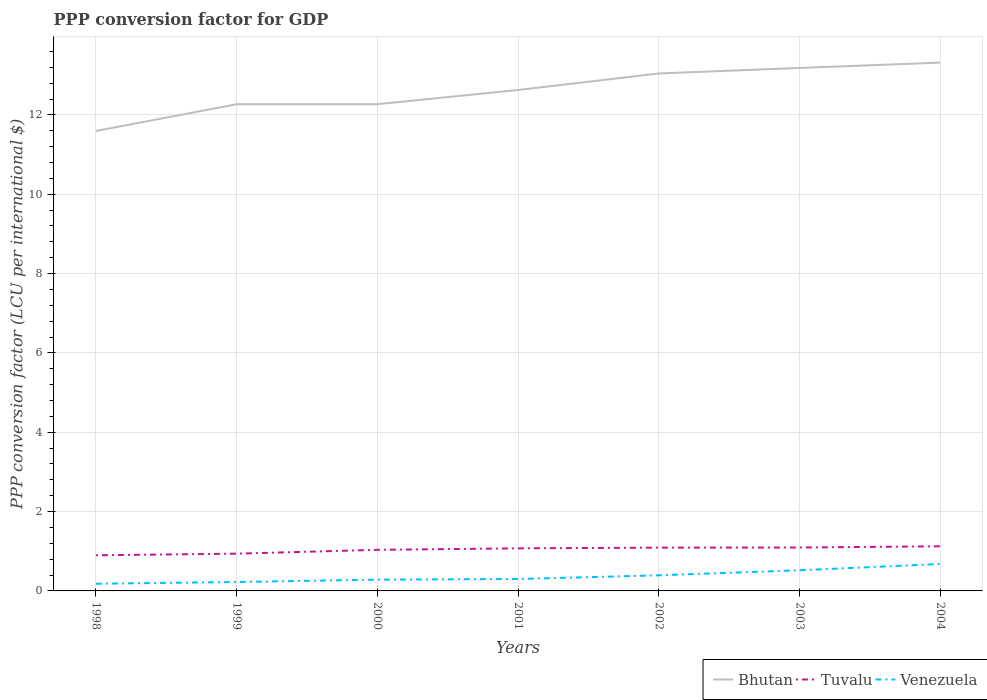How many different coloured lines are there?
Your answer should be very brief. 3. Does the line corresponding to Tuvalu intersect with the line corresponding to Venezuela?
Offer a terse response. No. Across all years, what is the maximum PPP conversion factor for GDP in Bhutan?
Provide a succinct answer. 11.59. In which year was the PPP conversion factor for GDP in Venezuela maximum?
Offer a terse response. 1998. What is the total PPP conversion factor for GDP in Tuvalu in the graph?
Your answer should be very brief. -0.05. What is the difference between the highest and the second highest PPP conversion factor for GDP in Venezuela?
Give a very brief answer. 0.5. What is the difference between the highest and the lowest PPP conversion factor for GDP in Tuvalu?
Make the answer very short. 4. Is the PPP conversion factor for GDP in Bhutan strictly greater than the PPP conversion factor for GDP in Venezuela over the years?
Your response must be concise. No. How many years are there in the graph?
Give a very brief answer. 7. Are the values on the major ticks of Y-axis written in scientific E-notation?
Make the answer very short. No. Does the graph contain grids?
Your response must be concise. Yes. Where does the legend appear in the graph?
Provide a succinct answer. Bottom right. How many legend labels are there?
Make the answer very short. 3. How are the legend labels stacked?
Keep it short and to the point. Horizontal. What is the title of the graph?
Offer a very short reply. PPP conversion factor for GDP. What is the label or title of the Y-axis?
Offer a very short reply. PPP conversion factor (LCU per international $). What is the PPP conversion factor (LCU per international $) in Bhutan in 1998?
Your answer should be compact. 11.59. What is the PPP conversion factor (LCU per international $) of Tuvalu in 1998?
Your answer should be compact. 0.9. What is the PPP conversion factor (LCU per international $) in Venezuela in 1998?
Keep it short and to the point. 0.18. What is the PPP conversion factor (LCU per international $) of Bhutan in 1999?
Your answer should be very brief. 12.27. What is the PPP conversion factor (LCU per international $) in Tuvalu in 1999?
Offer a terse response. 0.94. What is the PPP conversion factor (LCU per international $) of Venezuela in 1999?
Provide a short and direct response. 0.22. What is the PPP conversion factor (LCU per international $) of Bhutan in 2000?
Provide a succinct answer. 12.27. What is the PPP conversion factor (LCU per international $) in Tuvalu in 2000?
Ensure brevity in your answer.  1.04. What is the PPP conversion factor (LCU per international $) of Venezuela in 2000?
Give a very brief answer. 0.28. What is the PPP conversion factor (LCU per international $) of Bhutan in 2001?
Your answer should be very brief. 12.63. What is the PPP conversion factor (LCU per international $) in Tuvalu in 2001?
Offer a terse response. 1.07. What is the PPP conversion factor (LCU per international $) of Venezuela in 2001?
Your response must be concise. 0.3. What is the PPP conversion factor (LCU per international $) of Bhutan in 2002?
Offer a very short reply. 13.05. What is the PPP conversion factor (LCU per international $) of Tuvalu in 2002?
Make the answer very short. 1.09. What is the PPP conversion factor (LCU per international $) of Venezuela in 2002?
Keep it short and to the point. 0.39. What is the PPP conversion factor (LCU per international $) in Bhutan in 2003?
Ensure brevity in your answer.  13.18. What is the PPP conversion factor (LCU per international $) of Tuvalu in 2003?
Your answer should be compact. 1.09. What is the PPP conversion factor (LCU per international $) in Venezuela in 2003?
Your answer should be very brief. 0.52. What is the PPP conversion factor (LCU per international $) of Bhutan in 2004?
Keep it short and to the point. 13.32. What is the PPP conversion factor (LCU per international $) in Tuvalu in 2004?
Your answer should be compact. 1.12. What is the PPP conversion factor (LCU per international $) in Venezuela in 2004?
Provide a succinct answer. 0.68. Across all years, what is the maximum PPP conversion factor (LCU per international $) of Bhutan?
Offer a terse response. 13.32. Across all years, what is the maximum PPP conversion factor (LCU per international $) in Tuvalu?
Offer a terse response. 1.12. Across all years, what is the maximum PPP conversion factor (LCU per international $) of Venezuela?
Your answer should be compact. 0.68. Across all years, what is the minimum PPP conversion factor (LCU per international $) in Bhutan?
Your answer should be compact. 11.59. Across all years, what is the minimum PPP conversion factor (LCU per international $) of Tuvalu?
Offer a terse response. 0.9. Across all years, what is the minimum PPP conversion factor (LCU per international $) of Venezuela?
Your answer should be compact. 0.18. What is the total PPP conversion factor (LCU per international $) in Bhutan in the graph?
Make the answer very short. 88.31. What is the total PPP conversion factor (LCU per international $) in Tuvalu in the graph?
Make the answer very short. 7.26. What is the total PPP conversion factor (LCU per international $) of Venezuela in the graph?
Ensure brevity in your answer.  2.59. What is the difference between the PPP conversion factor (LCU per international $) of Bhutan in 1998 and that in 1999?
Provide a succinct answer. -0.67. What is the difference between the PPP conversion factor (LCU per international $) of Tuvalu in 1998 and that in 1999?
Give a very brief answer. -0.04. What is the difference between the PPP conversion factor (LCU per international $) of Venezuela in 1998 and that in 1999?
Give a very brief answer. -0.04. What is the difference between the PPP conversion factor (LCU per international $) of Bhutan in 1998 and that in 2000?
Provide a succinct answer. -0.68. What is the difference between the PPP conversion factor (LCU per international $) of Tuvalu in 1998 and that in 2000?
Ensure brevity in your answer.  -0.14. What is the difference between the PPP conversion factor (LCU per international $) of Venezuela in 1998 and that in 2000?
Make the answer very short. -0.1. What is the difference between the PPP conversion factor (LCU per international $) in Bhutan in 1998 and that in 2001?
Ensure brevity in your answer.  -1.03. What is the difference between the PPP conversion factor (LCU per international $) of Tuvalu in 1998 and that in 2001?
Give a very brief answer. -0.17. What is the difference between the PPP conversion factor (LCU per international $) of Venezuela in 1998 and that in 2001?
Make the answer very short. -0.12. What is the difference between the PPP conversion factor (LCU per international $) of Bhutan in 1998 and that in 2002?
Your response must be concise. -1.45. What is the difference between the PPP conversion factor (LCU per international $) of Tuvalu in 1998 and that in 2002?
Your answer should be compact. -0.19. What is the difference between the PPP conversion factor (LCU per international $) of Venezuela in 1998 and that in 2002?
Your response must be concise. -0.21. What is the difference between the PPP conversion factor (LCU per international $) of Bhutan in 1998 and that in 2003?
Your answer should be compact. -1.59. What is the difference between the PPP conversion factor (LCU per international $) in Tuvalu in 1998 and that in 2003?
Give a very brief answer. -0.2. What is the difference between the PPP conversion factor (LCU per international $) of Venezuela in 1998 and that in 2003?
Keep it short and to the point. -0.34. What is the difference between the PPP conversion factor (LCU per international $) of Bhutan in 1998 and that in 2004?
Your answer should be very brief. -1.72. What is the difference between the PPP conversion factor (LCU per international $) of Tuvalu in 1998 and that in 2004?
Your answer should be very brief. -0.23. What is the difference between the PPP conversion factor (LCU per international $) in Venezuela in 1998 and that in 2004?
Give a very brief answer. -0.5. What is the difference between the PPP conversion factor (LCU per international $) in Bhutan in 1999 and that in 2000?
Keep it short and to the point. -0. What is the difference between the PPP conversion factor (LCU per international $) of Tuvalu in 1999 and that in 2000?
Offer a terse response. -0.1. What is the difference between the PPP conversion factor (LCU per international $) of Venezuela in 1999 and that in 2000?
Provide a short and direct response. -0.06. What is the difference between the PPP conversion factor (LCU per international $) in Bhutan in 1999 and that in 2001?
Make the answer very short. -0.36. What is the difference between the PPP conversion factor (LCU per international $) in Tuvalu in 1999 and that in 2001?
Offer a terse response. -0.13. What is the difference between the PPP conversion factor (LCU per international $) in Venezuela in 1999 and that in 2001?
Offer a terse response. -0.08. What is the difference between the PPP conversion factor (LCU per international $) of Bhutan in 1999 and that in 2002?
Provide a short and direct response. -0.78. What is the difference between the PPP conversion factor (LCU per international $) in Tuvalu in 1999 and that in 2002?
Offer a terse response. -0.15. What is the difference between the PPP conversion factor (LCU per international $) of Venezuela in 1999 and that in 2002?
Your response must be concise. -0.17. What is the difference between the PPP conversion factor (LCU per international $) of Bhutan in 1999 and that in 2003?
Your answer should be very brief. -0.92. What is the difference between the PPP conversion factor (LCU per international $) in Tuvalu in 1999 and that in 2003?
Ensure brevity in your answer.  -0.16. What is the difference between the PPP conversion factor (LCU per international $) of Venezuela in 1999 and that in 2003?
Provide a succinct answer. -0.3. What is the difference between the PPP conversion factor (LCU per international $) of Bhutan in 1999 and that in 2004?
Provide a short and direct response. -1.05. What is the difference between the PPP conversion factor (LCU per international $) of Tuvalu in 1999 and that in 2004?
Your response must be concise. -0.19. What is the difference between the PPP conversion factor (LCU per international $) of Venezuela in 1999 and that in 2004?
Your answer should be very brief. -0.45. What is the difference between the PPP conversion factor (LCU per international $) of Bhutan in 2000 and that in 2001?
Provide a short and direct response. -0.36. What is the difference between the PPP conversion factor (LCU per international $) of Tuvalu in 2000 and that in 2001?
Provide a succinct answer. -0.04. What is the difference between the PPP conversion factor (LCU per international $) in Venezuela in 2000 and that in 2001?
Your answer should be compact. -0.02. What is the difference between the PPP conversion factor (LCU per international $) of Bhutan in 2000 and that in 2002?
Your response must be concise. -0.77. What is the difference between the PPP conversion factor (LCU per international $) of Tuvalu in 2000 and that in 2002?
Your answer should be very brief. -0.06. What is the difference between the PPP conversion factor (LCU per international $) of Venezuela in 2000 and that in 2002?
Your response must be concise. -0.11. What is the difference between the PPP conversion factor (LCU per international $) of Bhutan in 2000 and that in 2003?
Your answer should be compact. -0.91. What is the difference between the PPP conversion factor (LCU per international $) of Tuvalu in 2000 and that in 2003?
Keep it short and to the point. -0.06. What is the difference between the PPP conversion factor (LCU per international $) in Venezuela in 2000 and that in 2003?
Your answer should be compact. -0.24. What is the difference between the PPP conversion factor (LCU per international $) in Bhutan in 2000 and that in 2004?
Your response must be concise. -1.05. What is the difference between the PPP conversion factor (LCU per international $) of Tuvalu in 2000 and that in 2004?
Give a very brief answer. -0.09. What is the difference between the PPP conversion factor (LCU per international $) of Venezuela in 2000 and that in 2004?
Make the answer very short. -0.39. What is the difference between the PPP conversion factor (LCU per international $) of Bhutan in 2001 and that in 2002?
Make the answer very short. -0.42. What is the difference between the PPP conversion factor (LCU per international $) in Tuvalu in 2001 and that in 2002?
Keep it short and to the point. -0.02. What is the difference between the PPP conversion factor (LCU per international $) in Venezuela in 2001 and that in 2002?
Provide a succinct answer. -0.09. What is the difference between the PPP conversion factor (LCU per international $) of Bhutan in 2001 and that in 2003?
Offer a very short reply. -0.56. What is the difference between the PPP conversion factor (LCU per international $) in Tuvalu in 2001 and that in 2003?
Offer a terse response. -0.02. What is the difference between the PPP conversion factor (LCU per international $) in Venezuela in 2001 and that in 2003?
Your answer should be very brief. -0.22. What is the difference between the PPP conversion factor (LCU per international $) of Bhutan in 2001 and that in 2004?
Offer a terse response. -0.69. What is the difference between the PPP conversion factor (LCU per international $) of Tuvalu in 2001 and that in 2004?
Provide a short and direct response. -0.05. What is the difference between the PPP conversion factor (LCU per international $) of Venezuela in 2001 and that in 2004?
Ensure brevity in your answer.  -0.38. What is the difference between the PPP conversion factor (LCU per international $) in Bhutan in 2002 and that in 2003?
Give a very brief answer. -0.14. What is the difference between the PPP conversion factor (LCU per international $) of Tuvalu in 2002 and that in 2003?
Offer a very short reply. -0. What is the difference between the PPP conversion factor (LCU per international $) of Venezuela in 2002 and that in 2003?
Keep it short and to the point. -0.13. What is the difference between the PPP conversion factor (LCU per international $) in Bhutan in 2002 and that in 2004?
Your response must be concise. -0.27. What is the difference between the PPP conversion factor (LCU per international $) of Tuvalu in 2002 and that in 2004?
Your response must be concise. -0.03. What is the difference between the PPP conversion factor (LCU per international $) in Venezuela in 2002 and that in 2004?
Give a very brief answer. -0.29. What is the difference between the PPP conversion factor (LCU per international $) of Bhutan in 2003 and that in 2004?
Your answer should be very brief. -0.13. What is the difference between the PPP conversion factor (LCU per international $) of Tuvalu in 2003 and that in 2004?
Keep it short and to the point. -0.03. What is the difference between the PPP conversion factor (LCU per international $) of Venezuela in 2003 and that in 2004?
Offer a very short reply. -0.16. What is the difference between the PPP conversion factor (LCU per international $) of Bhutan in 1998 and the PPP conversion factor (LCU per international $) of Tuvalu in 1999?
Your answer should be compact. 10.66. What is the difference between the PPP conversion factor (LCU per international $) of Bhutan in 1998 and the PPP conversion factor (LCU per international $) of Venezuela in 1999?
Your answer should be very brief. 11.37. What is the difference between the PPP conversion factor (LCU per international $) of Tuvalu in 1998 and the PPP conversion factor (LCU per international $) of Venezuela in 1999?
Ensure brevity in your answer.  0.67. What is the difference between the PPP conversion factor (LCU per international $) of Bhutan in 1998 and the PPP conversion factor (LCU per international $) of Tuvalu in 2000?
Your answer should be compact. 10.56. What is the difference between the PPP conversion factor (LCU per international $) in Bhutan in 1998 and the PPP conversion factor (LCU per international $) in Venezuela in 2000?
Offer a terse response. 11.31. What is the difference between the PPP conversion factor (LCU per international $) of Tuvalu in 1998 and the PPP conversion factor (LCU per international $) of Venezuela in 2000?
Provide a succinct answer. 0.61. What is the difference between the PPP conversion factor (LCU per international $) of Bhutan in 1998 and the PPP conversion factor (LCU per international $) of Tuvalu in 2001?
Offer a terse response. 10.52. What is the difference between the PPP conversion factor (LCU per international $) in Bhutan in 1998 and the PPP conversion factor (LCU per international $) in Venezuela in 2001?
Your answer should be very brief. 11.29. What is the difference between the PPP conversion factor (LCU per international $) of Tuvalu in 1998 and the PPP conversion factor (LCU per international $) of Venezuela in 2001?
Give a very brief answer. 0.6. What is the difference between the PPP conversion factor (LCU per international $) in Bhutan in 1998 and the PPP conversion factor (LCU per international $) in Tuvalu in 2002?
Your response must be concise. 10.5. What is the difference between the PPP conversion factor (LCU per international $) in Bhutan in 1998 and the PPP conversion factor (LCU per international $) in Venezuela in 2002?
Offer a very short reply. 11.2. What is the difference between the PPP conversion factor (LCU per international $) of Tuvalu in 1998 and the PPP conversion factor (LCU per international $) of Venezuela in 2002?
Your answer should be compact. 0.5. What is the difference between the PPP conversion factor (LCU per international $) in Bhutan in 1998 and the PPP conversion factor (LCU per international $) in Tuvalu in 2003?
Your answer should be very brief. 10.5. What is the difference between the PPP conversion factor (LCU per international $) of Bhutan in 1998 and the PPP conversion factor (LCU per international $) of Venezuela in 2003?
Provide a succinct answer. 11.07. What is the difference between the PPP conversion factor (LCU per international $) in Tuvalu in 1998 and the PPP conversion factor (LCU per international $) in Venezuela in 2003?
Give a very brief answer. 0.38. What is the difference between the PPP conversion factor (LCU per international $) of Bhutan in 1998 and the PPP conversion factor (LCU per international $) of Tuvalu in 2004?
Your response must be concise. 10.47. What is the difference between the PPP conversion factor (LCU per international $) of Bhutan in 1998 and the PPP conversion factor (LCU per international $) of Venezuela in 2004?
Provide a short and direct response. 10.92. What is the difference between the PPP conversion factor (LCU per international $) of Tuvalu in 1998 and the PPP conversion factor (LCU per international $) of Venezuela in 2004?
Your response must be concise. 0.22. What is the difference between the PPP conversion factor (LCU per international $) in Bhutan in 1999 and the PPP conversion factor (LCU per international $) in Tuvalu in 2000?
Ensure brevity in your answer.  11.23. What is the difference between the PPP conversion factor (LCU per international $) in Bhutan in 1999 and the PPP conversion factor (LCU per international $) in Venezuela in 2000?
Offer a very short reply. 11.98. What is the difference between the PPP conversion factor (LCU per international $) in Tuvalu in 1999 and the PPP conversion factor (LCU per international $) in Venezuela in 2000?
Provide a short and direct response. 0.65. What is the difference between the PPP conversion factor (LCU per international $) in Bhutan in 1999 and the PPP conversion factor (LCU per international $) in Tuvalu in 2001?
Keep it short and to the point. 11.2. What is the difference between the PPP conversion factor (LCU per international $) in Bhutan in 1999 and the PPP conversion factor (LCU per international $) in Venezuela in 2001?
Give a very brief answer. 11.97. What is the difference between the PPP conversion factor (LCU per international $) of Tuvalu in 1999 and the PPP conversion factor (LCU per international $) of Venezuela in 2001?
Your answer should be very brief. 0.64. What is the difference between the PPP conversion factor (LCU per international $) in Bhutan in 1999 and the PPP conversion factor (LCU per international $) in Tuvalu in 2002?
Ensure brevity in your answer.  11.18. What is the difference between the PPP conversion factor (LCU per international $) in Bhutan in 1999 and the PPP conversion factor (LCU per international $) in Venezuela in 2002?
Offer a very short reply. 11.88. What is the difference between the PPP conversion factor (LCU per international $) of Tuvalu in 1999 and the PPP conversion factor (LCU per international $) of Venezuela in 2002?
Provide a succinct answer. 0.55. What is the difference between the PPP conversion factor (LCU per international $) of Bhutan in 1999 and the PPP conversion factor (LCU per international $) of Tuvalu in 2003?
Offer a very short reply. 11.17. What is the difference between the PPP conversion factor (LCU per international $) of Bhutan in 1999 and the PPP conversion factor (LCU per international $) of Venezuela in 2003?
Offer a very short reply. 11.75. What is the difference between the PPP conversion factor (LCU per international $) in Tuvalu in 1999 and the PPP conversion factor (LCU per international $) in Venezuela in 2003?
Offer a terse response. 0.42. What is the difference between the PPP conversion factor (LCU per international $) of Bhutan in 1999 and the PPP conversion factor (LCU per international $) of Tuvalu in 2004?
Ensure brevity in your answer.  11.14. What is the difference between the PPP conversion factor (LCU per international $) in Bhutan in 1999 and the PPP conversion factor (LCU per international $) in Venezuela in 2004?
Keep it short and to the point. 11.59. What is the difference between the PPP conversion factor (LCU per international $) of Tuvalu in 1999 and the PPP conversion factor (LCU per international $) of Venezuela in 2004?
Give a very brief answer. 0.26. What is the difference between the PPP conversion factor (LCU per international $) in Bhutan in 2000 and the PPP conversion factor (LCU per international $) in Tuvalu in 2001?
Provide a short and direct response. 11.2. What is the difference between the PPP conversion factor (LCU per international $) of Bhutan in 2000 and the PPP conversion factor (LCU per international $) of Venezuela in 2001?
Keep it short and to the point. 11.97. What is the difference between the PPP conversion factor (LCU per international $) in Tuvalu in 2000 and the PPP conversion factor (LCU per international $) in Venezuela in 2001?
Make the answer very short. 0.74. What is the difference between the PPP conversion factor (LCU per international $) of Bhutan in 2000 and the PPP conversion factor (LCU per international $) of Tuvalu in 2002?
Ensure brevity in your answer.  11.18. What is the difference between the PPP conversion factor (LCU per international $) in Bhutan in 2000 and the PPP conversion factor (LCU per international $) in Venezuela in 2002?
Offer a terse response. 11.88. What is the difference between the PPP conversion factor (LCU per international $) in Tuvalu in 2000 and the PPP conversion factor (LCU per international $) in Venezuela in 2002?
Offer a terse response. 0.64. What is the difference between the PPP conversion factor (LCU per international $) in Bhutan in 2000 and the PPP conversion factor (LCU per international $) in Tuvalu in 2003?
Your answer should be very brief. 11.18. What is the difference between the PPP conversion factor (LCU per international $) in Bhutan in 2000 and the PPP conversion factor (LCU per international $) in Venezuela in 2003?
Ensure brevity in your answer.  11.75. What is the difference between the PPP conversion factor (LCU per international $) in Tuvalu in 2000 and the PPP conversion factor (LCU per international $) in Venezuela in 2003?
Your answer should be compact. 0.52. What is the difference between the PPP conversion factor (LCU per international $) of Bhutan in 2000 and the PPP conversion factor (LCU per international $) of Tuvalu in 2004?
Provide a short and direct response. 11.15. What is the difference between the PPP conversion factor (LCU per international $) of Bhutan in 2000 and the PPP conversion factor (LCU per international $) of Venezuela in 2004?
Provide a short and direct response. 11.59. What is the difference between the PPP conversion factor (LCU per international $) in Tuvalu in 2000 and the PPP conversion factor (LCU per international $) in Venezuela in 2004?
Provide a short and direct response. 0.36. What is the difference between the PPP conversion factor (LCU per international $) in Bhutan in 2001 and the PPP conversion factor (LCU per international $) in Tuvalu in 2002?
Offer a terse response. 11.54. What is the difference between the PPP conversion factor (LCU per international $) in Bhutan in 2001 and the PPP conversion factor (LCU per international $) in Venezuela in 2002?
Offer a very short reply. 12.23. What is the difference between the PPP conversion factor (LCU per international $) of Tuvalu in 2001 and the PPP conversion factor (LCU per international $) of Venezuela in 2002?
Keep it short and to the point. 0.68. What is the difference between the PPP conversion factor (LCU per international $) in Bhutan in 2001 and the PPP conversion factor (LCU per international $) in Tuvalu in 2003?
Ensure brevity in your answer.  11.53. What is the difference between the PPP conversion factor (LCU per international $) of Bhutan in 2001 and the PPP conversion factor (LCU per international $) of Venezuela in 2003?
Your answer should be compact. 12.11. What is the difference between the PPP conversion factor (LCU per international $) of Tuvalu in 2001 and the PPP conversion factor (LCU per international $) of Venezuela in 2003?
Your response must be concise. 0.55. What is the difference between the PPP conversion factor (LCU per international $) of Bhutan in 2001 and the PPP conversion factor (LCU per international $) of Tuvalu in 2004?
Keep it short and to the point. 11.5. What is the difference between the PPP conversion factor (LCU per international $) in Bhutan in 2001 and the PPP conversion factor (LCU per international $) in Venezuela in 2004?
Offer a terse response. 11.95. What is the difference between the PPP conversion factor (LCU per international $) of Tuvalu in 2001 and the PPP conversion factor (LCU per international $) of Venezuela in 2004?
Your response must be concise. 0.39. What is the difference between the PPP conversion factor (LCU per international $) in Bhutan in 2002 and the PPP conversion factor (LCU per international $) in Tuvalu in 2003?
Ensure brevity in your answer.  11.95. What is the difference between the PPP conversion factor (LCU per international $) in Bhutan in 2002 and the PPP conversion factor (LCU per international $) in Venezuela in 2003?
Your response must be concise. 12.52. What is the difference between the PPP conversion factor (LCU per international $) in Tuvalu in 2002 and the PPP conversion factor (LCU per international $) in Venezuela in 2003?
Your answer should be compact. 0.57. What is the difference between the PPP conversion factor (LCU per international $) in Bhutan in 2002 and the PPP conversion factor (LCU per international $) in Tuvalu in 2004?
Give a very brief answer. 11.92. What is the difference between the PPP conversion factor (LCU per international $) in Bhutan in 2002 and the PPP conversion factor (LCU per international $) in Venezuela in 2004?
Keep it short and to the point. 12.37. What is the difference between the PPP conversion factor (LCU per international $) of Tuvalu in 2002 and the PPP conversion factor (LCU per international $) of Venezuela in 2004?
Ensure brevity in your answer.  0.41. What is the difference between the PPP conversion factor (LCU per international $) in Bhutan in 2003 and the PPP conversion factor (LCU per international $) in Tuvalu in 2004?
Provide a short and direct response. 12.06. What is the difference between the PPP conversion factor (LCU per international $) in Bhutan in 2003 and the PPP conversion factor (LCU per international $) in Venezuela in 2004?
Provide a succinct answer. 12.51. What is the difference between the PPP conversion factor (LCU per international $) in Tuvalu in 2003 and the PPP conversion factor (LCU per international $) in Venezuela in 2004?
Your answer should be compact. 0.42. What is the average PPP conversion factor (LCU per international $) of Bhutan per year?
Give a very brief answer. 12.62. What is the average PPP conversion factor (LCU per international $) of Tuvalu per year?
Your response must be concise. 1.04. What is the average PPP conversion factor (LCU per international $) in Venezuela per year?
Offer a terse response. 0.37. In the year 1998, what is the difference between the PPP conversion factor (LCU per international $) in Bhutan and PPP conversion factor (LCU per international $) in Tuvalu?
Your answer should be very brief. 10.7. In the year 1998, what is the difference between the PPP conversion factor (LCU per international $) of Bhutan and PPP conversion factor (LCU per international $) of Venezuela?
Your response must be concise. 11.41. In the year 1998, what is the difference between the PPP conversion factor (LCU per international $) in Tuvalu and PPP conversion factor (LCU per international $) in Venezuela?
Provide a succinct answer. 0.72. In the year 1999, what is the difference between the PPP conversion factor (LCU per international $) in Bhutan and PPP conversion factor (LCU per international $) in Tuvalu?
Your answer should be very brief. 11.33. In the year 1999, what is the difference between the PPP conversion factor (LCU per international $) in Bhutan and PPP conversion factor (LCU per international $) in Venezuela?
Ensure brevity in your answer.  12.04. In the year 1999, what is the difference between the PPP conversion factor (LCU per international $) in Tuvalu and PPP conversion factor (LCU per international $) in Venezuela?
Make the answer very short. 0.71. In the year 2000, what is the difference between the PPP conversion factor (LCU per international $) in Bhutan and PPP conversion factor (LCU per international $) in Tuvalu?
Your answer should be very brief. 11.23. In the year 2000, what is the difference between the PPP conversion factor (LCU per international $) in Bhutan and PPP conversion factor (LCU per international $) in Venezuela?
Your response must be concise. 11.99. In the year 2000, what is the difference between the PPP conversion factor (LCU per international $) in Tuvalu and PPP conversion factor (LCU per international $) in Venezuela?
Your answer should be compact. 0.75. In the year 2001, what is the difference between the PPP conversion factor (LCU per international $) of Bhutan and PPP conversion factor (LCU per international $) of Tuvalu?
Provide a short and direct response. 11.56. In the year 2001, what is the difference between the PPP conversion factor (LCU per international $) in Bhutan and PPP conversion factor (LCU per international $) in Venezuela?
Your response must be concise. 12.33. In the year 2001, what is the difference between the PPP conversion factor (LCU per international $) in Tuvalu and PPP conversion factor (LCU per international $) in Venezuela?
Your answer should be compact. 0.77. In the year 2002, what is the difference between the PPP conversion factor (LCU per international $) of Bhutan and PPP conversion factor (LCU per international $) of Tuvalu?
Your answer should be very brief. 11.95. In the year 2002, what is the difference between the PPP conversion factor (LCU per international $) of Bhutan and PPP conversion factor (LCU per international $) of Venezuela?
Give a very brief answer. 12.65. In the year 2002, what is the difference between the PPP conversion factor (LCU per international $) in Tuvalu and PPP conversion factor (LCU per international $) in Venezuela?
Offer a very short reply. 0.7. In the year 2003, what is the difference between the PPP conversion factor (LCU per international $) in Bhutan and PPP conversion factor (LCU per international $) in Tuvalu?
Your response must be concise. 12.09. In the year 2003, what is the difference between the PPP conversion factor (LCU per international $) in Bhutan and PPP conversion factor (LCU per international $) in Venezuela?
Your response must be concise. 12.66. In the year 2003, what is the difference between the PPP conversion factor (LCU per international $) of Tuvalu and PPP conversion factor (LCU per international $) of Venezuela?
Provide a short and direct response. 0.57. In the year 2004, what is the difference between the PPP conversion factor (LCU per international $) of Bhutan and PPP conversion factor (LCU per international $) of Tuvalu?
Your answer should be compact. 12.19. In the year 2004, what is the difference between the PPP conversion factor (LCU per international $) in Bhutan and PPP conversion factor (LCU per international $) in Venezuela?
Give a very brief answer. 12.64. In the year 2004, what is the difference between the PPP conversion factor (LCU per international $) of Tuvalu and PPP conversion factor (LCU per international $) of Venezuela?
Your answer should be very brief. 0.45. What is the ratio of the PPP conversion factor (LCU per international $) in Bhutan in 1998 to that in 1999?
Make the answer very short. 0.94. What is the ratio of the PPP conversion factor (LCU per international $) in Tuvalu in 1998 to that in 1999?
Keep it short and to the point. 0.96. What is the ratio of the PPP conversion factor (LCU per international $) in Venezuela in 1998 to that in 1999?
Give a very brief answer. 0.8. What is the ratio of the PPP conversion factor (LCU per international $) in Bhutan in 1998 to that in 2000?
Your response must be concise. 0.94. What is the ratio of the PPP conversion factor (LCU per international $) in Tuvalu in 1998 to that in 2000?
Make the answer very short. 0.87. What is the ratio of the PPP conversion factor (LCU per international $) in Venezuela in 1998 to that in 2000?
Provide a short and direct response. 0.64. What is the ratio of the PPP conversion factor (LCU per international $) of Bhutan in 1998 to that in 2001?
Ensure brevity in your answer.  0.92. What is the ratio of the PPP conversion factor (LCU per international $) in Tuvalu in 1998 to that in 2001?
Keep it short and to the point. 0.84. What is the ratio of the PPP conversion factor (LCU per international $) in Venezuela in 1998 to that in 2001?
Your response must be concise. 0.6. What is the ratio of the PPP conversion factor (LCU per international $) in Bhutan in 1998 to that in 2002?
Provide a succinct answer. 0.89. What is the ratio of the PPP conversion factor (LCU per international $) of Tuvalu in 1998 to that in 2002?
Provide a succinct answer. 0.82. What is the ratio of the PPP conversion factor (LCU per international $) of Venezuela in 1998 to that in 2002?
Offer a terse response. 0.46. What is the ratio of the PPP conversion factor (LCU per international $) of Bhutan in 1998 to that in 2003?
Your response must be concise. 0.88. What is the ratio of the PPP conversion factor (LCU per international $) in Tuvalu in 1998 to that in 2003?
Your answer should be compact. 0.82. What is the ratio of the PPP conversion factor (LCU per international $) in Venezuela in 1998 to that in 2003?
Offer a very short reply. 0.35. What is the ratio of the PPP conversion factor (LCU per international $) in Bhutan in 1998 to that in 2004?
Provide a succinct answer. 0.87. What is the ratio of the PPP conversion factor (LCU per international $) of Tuvalu in 1998 to that in 2004?
Make the answer very short. 0.8. What is the ratio of the PPP conversion factor (LCU per international $) in Venezuela in 1998 to that in 2004?
Keep it short and to the point. 0.27. What is the ratio of the PPP conversion factor (LCU per international $) in Bhutan in 1999 to that in 2000?
Offer a terse response. 1. What is the ratio of the PPP conversion factor (LCU per international $) of Tuvalu in 1999 to that in 2000?
Make the answer very short. 0.91. What is the ratio of the PPP conversion factor (LCU per international $) in Venezuela in 1999 to that in 2000?
Offer a terse response. 0.79. What is the ratio of the PPP conversion factor (LCU per international $) of Bhutan in 1999 to that in 2001?
Your response must be concise. 0.97. What is the ratio of the PPP conversion factor (LCU per international $) of Tuvalu in 1999 to that in 2001?
Offer a terse response. 0.88. What is the ratio of the PPP conversion factor (LCU per international $) in Venezuela in 1999 to that in 2001?
Ensure brevity in your answer.  0.75. What is the ratio of the PPP conversion factor (LCU per international $) of Bhutan in 1999 to that in 2002?
Provide a succinct answer. 0.94. What is the ratio of the PPP conversion factor (LCU per international $) of Tuvalu in 1999 to that in 2002?
Ensure brevity in your answer.  0.86. What is the ratio of the PPP conversion factor (LCU per international $) in Venezuela in 1999 to that in 2002?
Ensure brevity in your answer.  0.57. What is the ratio of the PPP conversion factor (LCU per international $) of Bhutan in 1999 to that in 2003?
Ensure brevity in your answer.  0.93. What is the ratio of the PPP conversion factor (LCU per international $) of Tuvalu in 1999 to that in 2003?
Provide a succinct answer. 0.86. What is the ratio of the PPP conversion factor (LCU per international $) of Venezuela in 1999 to that in 2003?
Make the answer very short. 0.43. What is the ratio of the PPP conversion factor (LCU per international $) in Bhutan in 1999 to that in 2004?
Make the answer very short. 0.92. What is the ratio of the PPP conversion factor (LCU per international $) of Tuvalu in 1999 to that in 2004?
Offer a very short reply. 0.83. What is the ratio of the PPP conversion factor (LCU per international $) of Venezuela in 1999 to that in 2004?
Keep it short and to the point. 0.33. What is the ratio of the PPP conversion factor (LCU per international $) of Bhutan in 2000 to that in 2001?
Offer a terse response. 0.97. What is the ratio of the PPP conversion factor (LCU per international $) of Tuvalu in 2000 to that in 2001?
Offer a very short reply. 0.97. What is the ratio of the PPP conversion factor (LCU per international $) of Venezuela in 2000 to that in 2001?
Ensure brevity in your answer.  0.95. What is the ratio of the PPP conversion factor (LCU per international $) of Bhutan in 2000 to that in 2002?
Provide a succinct answer. 0.94. What is the ratio of the PPP conversion factor (LCU per international $) in Tuvalu in 2000 to that in 2002?
Offer a terse response. 0.95. What is the ratio of the PPP conversion factor (LCU per international $) of Venezuela in 2000 to that in 2002?
Provide a short and direct response. 0.72. What is the ratio of the PPP conversion factor (LCU per international $) of Bhutan in 2000 to that in 2003?
Offer a terse response. 0.93. What is the ratio of the PPP conversion factor (LCU per international $) in Tuvalu in 2000 to that in 2003?
Make the answer very short. 0.95. What is the ratio of the PPP conversion factor (LCU per international $) of Venezuela in 2000 to that in 2003?
Provide a succinct answer. 0.55. What is the ratio of the PPP conversion factor (LCU per international $) of Bhutan in 2000 to that in 2004?
Ensure brevity in your answer.  0.92. What is the ratio of the PPP conversion factor (LCU per international $) in Tuvalu in 2000 to that in 2004?
Your answer should be compact. 0.92. What is the ratio of the PPP conversion factor (LCU per international $) of Venezuela in 2000 to that in 2004?
Provide a short and direct response. 0.42. What is the ratio of the PPP conversion factor (LCU per international $) in Bhutan in 2001 to that in 2002?
Keep it short and to the point. 0.97. What is the ratio of the PPP conversion factor (LCU per international $) in Tuvalu in 2001 to that in 2002?
Your response must be concise. 0.98. What is the ratio of the PPP conversion factor (LCU per international $) in Venezuela in 2001 to that in 2002?
Provide a short and direct response. 0.76. What is the ratio of the PPP conversion factor (LCU per international $) in Bhutan in 2001 to that in 2003?
Your response must be concise. 0.96. What is the ratio of the PPP conversion factor (LCU per international $) of Tuvalu in 2001 to that in 2003?
Provide a succinct answer. 0.98. What is the ratio of the PPP conversion factor (LCU per international $) in Venezuela in 2001 to that in 2003?
Your answer should be compact. 0.58. What is the ratio of the PPP conversion factor (LCU per international $) of Bhutan in 2001 to that in 2004?
Provide a short and direct response. 0.95. What is the ratio of the PPP conversion factor (LCU per international $) in Tuvalu in 2001 to that in 2004?
Your response must be concise. 0.95. What is the ratio of the PPP conversion factor (LCU per international $) in Venezuela in 2001 to that in 2004?
Make the answer very short. 0.44. What is the ratio of the PPP conversion factor (LCU per international $) in Venezuela in 2002 to that in 2003?
Give a very brief answer. 0.76. What is the ratio of the PPP conversion factor (LCU per international $) of Bhutan in 2002 to that in 2004?
Your answer should be compact. 0.98. What is the ratio of the PPP conversion factor (LCU per international $) in Tuvalu in 2002 to that in 2004?
Keep it short and to the point. 0.97. What is the ratio of the PPP conversion factor (LCU per international $) of Venezuela in 2002 to that in 2004?
Make the answer very short. 0.58. What is the ratio of the PPP conversion factor (LCU per international $) in Bhutan in 2003 to that in 2004?
Ensure brevity in your answer.  0.99. What is the ratio of the PPP conversion factor (LCU per international $) of Venezuela in 2003 to that in 2004?
Give a very brief answer. 0.77. What is the difference between the highest and the second highest PPP conversion factor (LCU per international $) of Bhutan?
Your response must be concise. 0.13. What is the difference between the highest and the second highest PPP conversion factor (LCU per international $) in Tuvalu?
Ensure brevity in your answer.  0.03. What is the difference between the highest and the second highest PPP conversion factor (LCU per international $) in Venezuela?
Give a very brief answer. 0.16. What is the difference between the highest and the lowest PPP conversion factor (LCU per international $) in Bhutan?
Offer a very short reply. 1.72. What is the difference between the highest and the lowest PPP conversion factor (LCU per international $) in Tuvalu?
Offer a terse response. 0.23. What is the difference between the highest and the lowest PPP conversion factor (LCU per international $) in Venezuela?
Offer a very short reply. 0.5. 